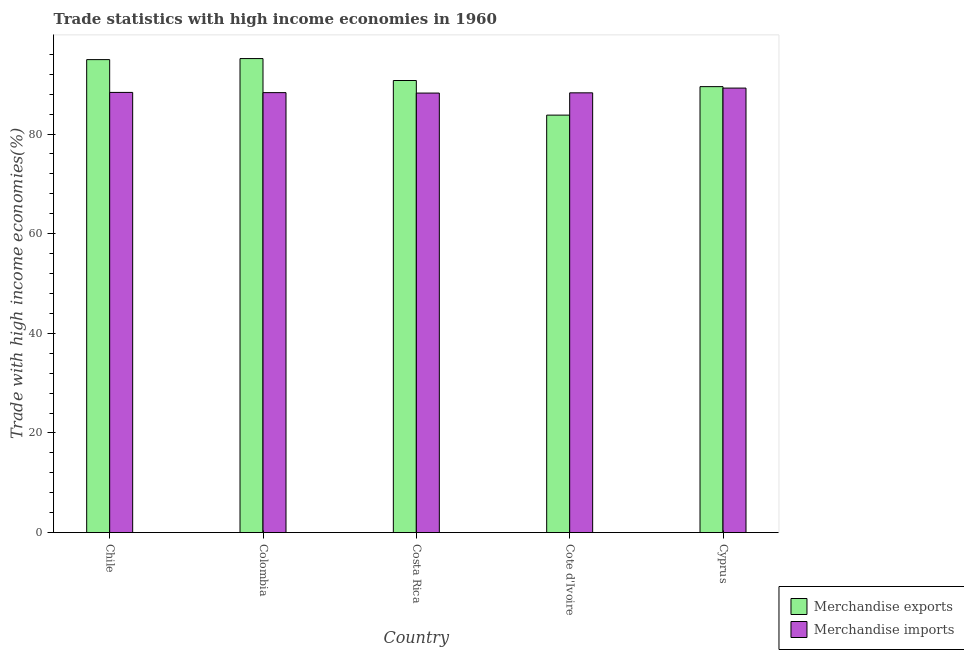How many different coloured bars are there?
Make the answer very short. 2. How many bars are there on the 3rd tick from the left?
Offer a terse response. 2. How many bars are there on the 2nd tick from the right?
Make the answer very short. 2. What is the label of the 3rd group of bars from the left?
Provide a short and direct response. Costa Rica. In how many cases, is the number of bars for a given country not equal to the number of legend labels?
Ensure brevity in your answer.  0. What is the merchandise exports in Cote d'Ivoire?
Your answer should be very brief. 83.8. Across all countries, what is the maximum merchandise exports?
Keep it short and to the point. 95.14. Across all countries, what is the minimum merchandise exports?
Your response must be concise. 83.8. In which country was the merchandise exports minimum?
Offer a very short reply. Cote d'Ivoire. What is the total merchandise exports in the graph?
Provide a short and direct response. 454.13. What is the difference between the merchandise exports in Colombia and that in Costa Rica?
Make the answer very short. 4.4. What is the difference between the merchandise exports in Chile and the merchandise imports in Cyprus?
Your answer should be very brief. 5.72. What is the average merchandise imports per country?
Your answer should be very brief. 88.47. What is the difference between the merchandise imports and merchandise exports in Cyprus?
Offer a terse response. -0.29. In how many countries, is the merchandise imports greater than 52 %?
Your response must be concise. 5. What is the ratio of the merchandise exports in Chile to that in Costa Rica?
Provide a short and direct response. 1.05. Is the merchandise exports in Chile less than that in Costa Rica?
Provide a short and direct response. No. Is the difference between the merchandise imports in Colombia and Cote d'Ivoire greater than the difference between the merchandise exports in Colombia and Cote d'Ivoire?
Keep it short and to the point. No. What is the difference between the highest and the second highest merchandise exports?
Make the answer very short. 0.21. What is the difference between the highest and the lowest merchandise imports?
Make the answer very short. 1. Is the sum of the merchandise exports in Chile and Colombia greater than the maximum merchandise imports across all countries?
Offer a terse response. Yes. Are all the bars in the graph horizontal?
Give a very brief answer. No. How many countries are there in the graph?
Provide a short and direct response. 5. What is the difference between two consecutive major ticks on the Y-axis?
Your answer should be very brief. 20. Are the values on the major ticks of Y-axis written in scientific E-notation?
Ensure brevity in your answer.  No. Where does the legend appear in the graph?
Give a very brief answer. Bottom right. How many legend labels are there?
Provide a succinct answer. 2. How are the legend labels stacked?
Offer a terse response. Vertical. What is the title of the graph?
Your answer should be compact. Trade statistics with high income economies in 1960. Does "Female population" appear as one of the legend labels in the graph?
Your answer should be compact. No. What is the label or title of the X-axis?
Make the answer very short. Country. What is the label or title of the Y-axis?
Make the answer very short. Trade with high income economies(%). What is the Trade with high income economies(%) of Merchandise exports in Chile?
Provide a succinct answer. 94.94. What is the Trade with high income economies(%) of Merchandise imports in Chile?
Offer a terse response. 88.35. What is the Trade with high income economies(%) of Merchandise exports in Colombia?
Offer a terse response. 95.14. What is the Trade with high income economies(%) of Merchandise imports in Colombia?
Provide a succinct answer. 88.31. What is the Trade with high income economies(%) in Merchandise exports in Costa Rica?
Your answer should be compact. 90.74. What is the Trade with high income economies(%) in Merchandise imports in Costa Rica?
Provide a succinct answer. 88.22. What is the Trade with high income economies(%) of Merchandise exports in Cote d'Ivoire?
Provide a short and direct response. 83.8. What is the Trade with high income economies(%) of Merchandise imports in Cote d'Ivoire?
Keep it short and to the point. 88.27. What is the Trade with high income economies(%) of Merchandise exports in Cyprus?
Your answer should be compact. 89.51. What is the Trade with high income economies(%) of Merchandise imports in Cyprus?
Give a very brief answer. 89.22. Across all countries, what is the maximum Trade with high income economies(%) of Merchandise exports?
Your answer should be compact. 95.14. Across all countries, what is the maximum Trade with high income economies(%) of Merchandise imports?
Provide a short and direct response. 89.22. Across all countries, what is the minimum Trade with high income economies(%) of Merchandise exports?
Provide a succinct answer. 83.8. Across all countries, what is the minimum Trade with high income economies(%) of Merchandise imports?
Give a very brief answer. 88.22. What is the total Trade with high income economies(%) of Merchandise exports in the graph?
Your answer should be very brief. 454.13. What is the total Trade with high income economies(%) in Merchandise imports in the graph?
Make the answer very short. 442.37. What is the difference between the Trade with high income economies(%) in Merchandise exports in Chile and that in Colombia?
Provide a succinct answer. -0.21. What is the difference between the Trade with high income economies(%) in Merchandise imports in Chile and that in Colombia?
Provide a short and direct response. 0.04. What is the difference between the Trade with high income economies(%) in Merchandise exports in Chile and that in Costa Rica?
Offer a very short reply. 4.19. What is the difference between the Trade with high income economies(%) in Merchandise imports in Chile and that in Costa Rica?
Offer a very short reply. 0.13. What is the difference between the Trade with high income economies(%) of Merchandise exports in Chile and that in Cote d'Ivoire?
Your answer should be compact. 11.14. What is the difference between the Trade with high income economies(%) of Merchandise imports in Chile and that in Cote d'Ivoire?
Your response must be concise. 0.09. What is the difference between the Trade with high income economies(%) of Merchandise exports in Chile and that in Cyprus?
Provide a succinct answer. 5.42. What is the difference between the Trade with high income economies(%) of Merchandise imports in Chile and that in Cyprus?
Your response must be concise. -0.87. What is the difference between the Trade with high income economies(%) of Merchandise exports in Colombia and that in Costa Rica?
Offer a very short reply. 4.4. What is the difference between the Trade with high income economies(%) of Merchandise imports in Colombia and that in Costa Rica?
Provide a short and direct response. 0.09. What is the difference between the Trade with high income economies(%) in Merchandise exports in Colombia and that in Cote d'Ivoire?
Your answer should be very brief. 11.35. What is the difference between the Trade with high income economies(%) in Merchandise imports in Colombia and that in Cote d'Ivoire?
Your answer should be compact. 0.04. What is the difference between the Trade with high income economies(%) of Merchandise exports in Colombia and that in Cyprus?
Offer a very short reply. 5.63. What is the difference between the Trade with high income economies(%) in Merchandise imports in Colombia and that in Cyprus?
Your response must be concise. -0.91. What is the difference between the Trade with high income economies(%) of Merchandise exports in Costa Rica and that in Cote d'Ivoire?
Your answer should be very brief. 6.95. What is the difference between the Trade with high income economies(%) of Merchandise imports in Costa Rica and that in Cote d'Ivoire?
Make the answer very short. -0.05. What is the difference between the Trade with high income economies(%) in Merchandise exports in Costa Rica and that in Cyprus?
Offer a very short reply. 1.23. What is the difference between the Trade with high income economies(%) of Merchandise imports in Costa Rica and that in Cyprus?
Keep it short and to the point. -1. What is the difference between the Trade with high income economies(%) in Merchandise exports in Cote d'Ivoire and that in Cyprus?
Your answer should be very brief. -5.72. What is the difference between the Trade with high income economies(%) in Merchandise imports in Cote d'Ivoire and that in Cyprus?
Provide a succinct answer. -0.95. What is the difference between the Trade with high income economies(%) of Merchandise exports in Chile and the Trade with high income economies(%) of Merchandise imports in Colombia?
Provide a short and direct response. 6.63. What is the difference between the Trade with high income economies(%) of Merchandise exports in Chile and the Trade with high income economies(%) of Merchandise imports in Costa Rica?
Offer a terse response. 6.72. What is the difference between the Trade with high income economies(%) in Merchandise exports in Chile and the Trade with high income economies(%) in Merchandise imports in Cote d'Ivoire?
Make the answer very short. 6.67. What is the difference between the Trade with high income economies(%) in Merchandise exports in Chile and the Trade with high income economies(%) in Merchandise imports in Cyprus?
Make the answer very short. 5.72. What is the difference between the Trade with high income economies(%) of Merchandise exports in Colombia and the Trade with high income economies(%) of Merchandise imports in Costa Rica?
Make the answer very short. 6.92. What is the difference between the Trade with high income economies(%) in Merchandise exports in Colombia and the Trade with high income economies(%) in Merchandise imports in Cote d'Ivoire?
Offer a very short reply. 6.88. What is the difference between the Trade with high income economies(%) of Merchandise exports in Colombia and the Trade with high income economies(%) of Merchandise imports in Cyprus?
Your answer should be compact. 5.92. What is the difference between the Trade with high income economies(%) of Merchandise exports in Costa Rica and the Trade with high income economies(%) of Merchandise imports in Cote d'Ivoire?
Provide a succinct answer. 2.47. What is the difference between the Trade with high income economies(%) in Merchandise exports in Costa Rica and the Trade with high income economies(%) in Merchandise imports in Cyprus?
Offer a very short reply. 1.52. What is the difference between the Trade with high income economies(%) in Merchandise exports in Cote d'Ivoire and the Trade with high income economies(%) in Merchandise imports in Cyprus?
Provide a short and direct response. -5.42. What is the average Trade with high income economies(%) of Merchandise exports per country?
Provide a succinct answer. 90.83. What is the average Trade with high income economies(%) of Merchandise imports per country?
Give a very brief answer. 88.47. What is the difference between the Trade with high income economies(%) in Merchandise exports and Trade with high income economies(%) in Merchandise imports in Chile?
Your response must be concise. 6.58. What is the difference between the Trade with high income economies(%) in Merchandise exports and Trade with high income economies(%) in Merchandise imports in Colombia?
Offer a very short reply. 6.84. What is the difference between the Trade with high income economies(%) in Merchandise exports and Trade with high income economies(%) in Merchandise imports in Costa Rica?
Offer a very short reply. 2.52. What is the difference between the Trade with high income economies(%) in Merchandise exports and Trade with high income economies(%) in Merchandise imports in Cote d'Ivoire?
Offer a very short reply. -4.47. What is the difference between the Trade with high income economies(%) in Merchandise exports and Trade with high income economies(%) in Merchandise imports in Cyprus?
Make the answer very short. 0.29. What is the ratio of the Trade with high income economies(%) of Merchandise exports in Chile to that in Colombia?
Your answer should be very brief. 1. What is the ratio of the Trade with high income economies(%) of Merchandise imports in Chile to that in Colombia?
Offer a very short reply. 1. What is the ratio of the Trade with high income economies(%) of Merchandise exports in Chile to that in Costa Rica?
Offer a terse response. 1.05. What is the ratio of the Trade with high income economies(%) of Merchandise imports in Chile to that in Costa Rica?
Offer a terse response. 1. What is the ratio of the Trade with high income economies(%) of Merchandise exports in Chile to that in Cote d'Ivoire?
Provide a succinct answer. 1.13. What is the ratio of the Trade with high income economies(%) of Merchandise exports in Chile to that in Cyprus?
Provide a succinct answer. 1.06. What is the ratio of the Trade with high income economies(%) in Merchandise imports in Chile to that in Cyprus?
Give a very brief answer. 0.99. What is the ratio of the Trade with high income economies(%) of Merchandise exports in Colombia to that in Costa Rica?
Make the answer very short. 1.05. What is the ratio of the Trade with high income economies(%) of Merchandise imports in Colombia to that in Costa Rica?
Give a very brief answer. 1. What is the ratio of the Trade with high income economies(%) in Merchandise exports in Colombia to that in Cote d'Ivoire?
Your answer should be compact. 1.14. What is the ratio of the Trade with high income economies(%) of Merchandise imports in Colombia to that in Cote d'Ivoire?
Provide a succinct answer. 1. What is the ratio of the Trade with high income economies(%) in Merchandise exports in Colombia to that in Cyprus?
Make the answer very short. 1.06. What is the ratio of the Trade with high income economies(%) of Merchandise imports in Colombia to that in Cyprus?
Keep it short and to the point. 0.99. What is the ratio of the Trade with high income economies(%) of Merchandise exports in Costa Rica to that in Cote d'Ivoire?
Keep it short and to the point. 1.08. What is the ratio of the Trade with high income economies(%) in Merchandise imports in Costa Rica to that in Cote d'Ivoire?
Offer a terse response. 1. What is the ratio of the Trade with high income economies(%) in Merchandise exports in Costa Rica to that in Cyprus?
Ensure brevity in your answer.  1.01. What is the ratio of the Trade with high income economies(%) in Merchandise imports in Costa Rica to that in Cyprus?
Your answer should be compact. 0.99. What is the ratio of the Trade with high income economies(%) in Merchandise exports in Cote d'Ivoire to that in Cyprus?
Your answer should be compact. 0.94. What is the ratio of the Trade with high income economies(%) in Merchandise imports in Cote d'Ivoire to that in Cyprus?
Make the answer very short. 0.99. What is the difference between the highest and the second highest Trade with high income economies(%) in Merchandise exports?
Give a very brief answer. 0.21. What is the difference between the highest and the second highest Trade with high income economies(%) in Merchandise imports?
Keep it short and to the point. 0.87. What is the difference between the highest and the lowest Trade with high income economies(%) of Merchandise exports?
Provide a short and direct response. 11.35. What is the difference between the highest and the lowest Trade with high income economies(%) in Merchandise imports?
Provide a succinct answer. 1. 